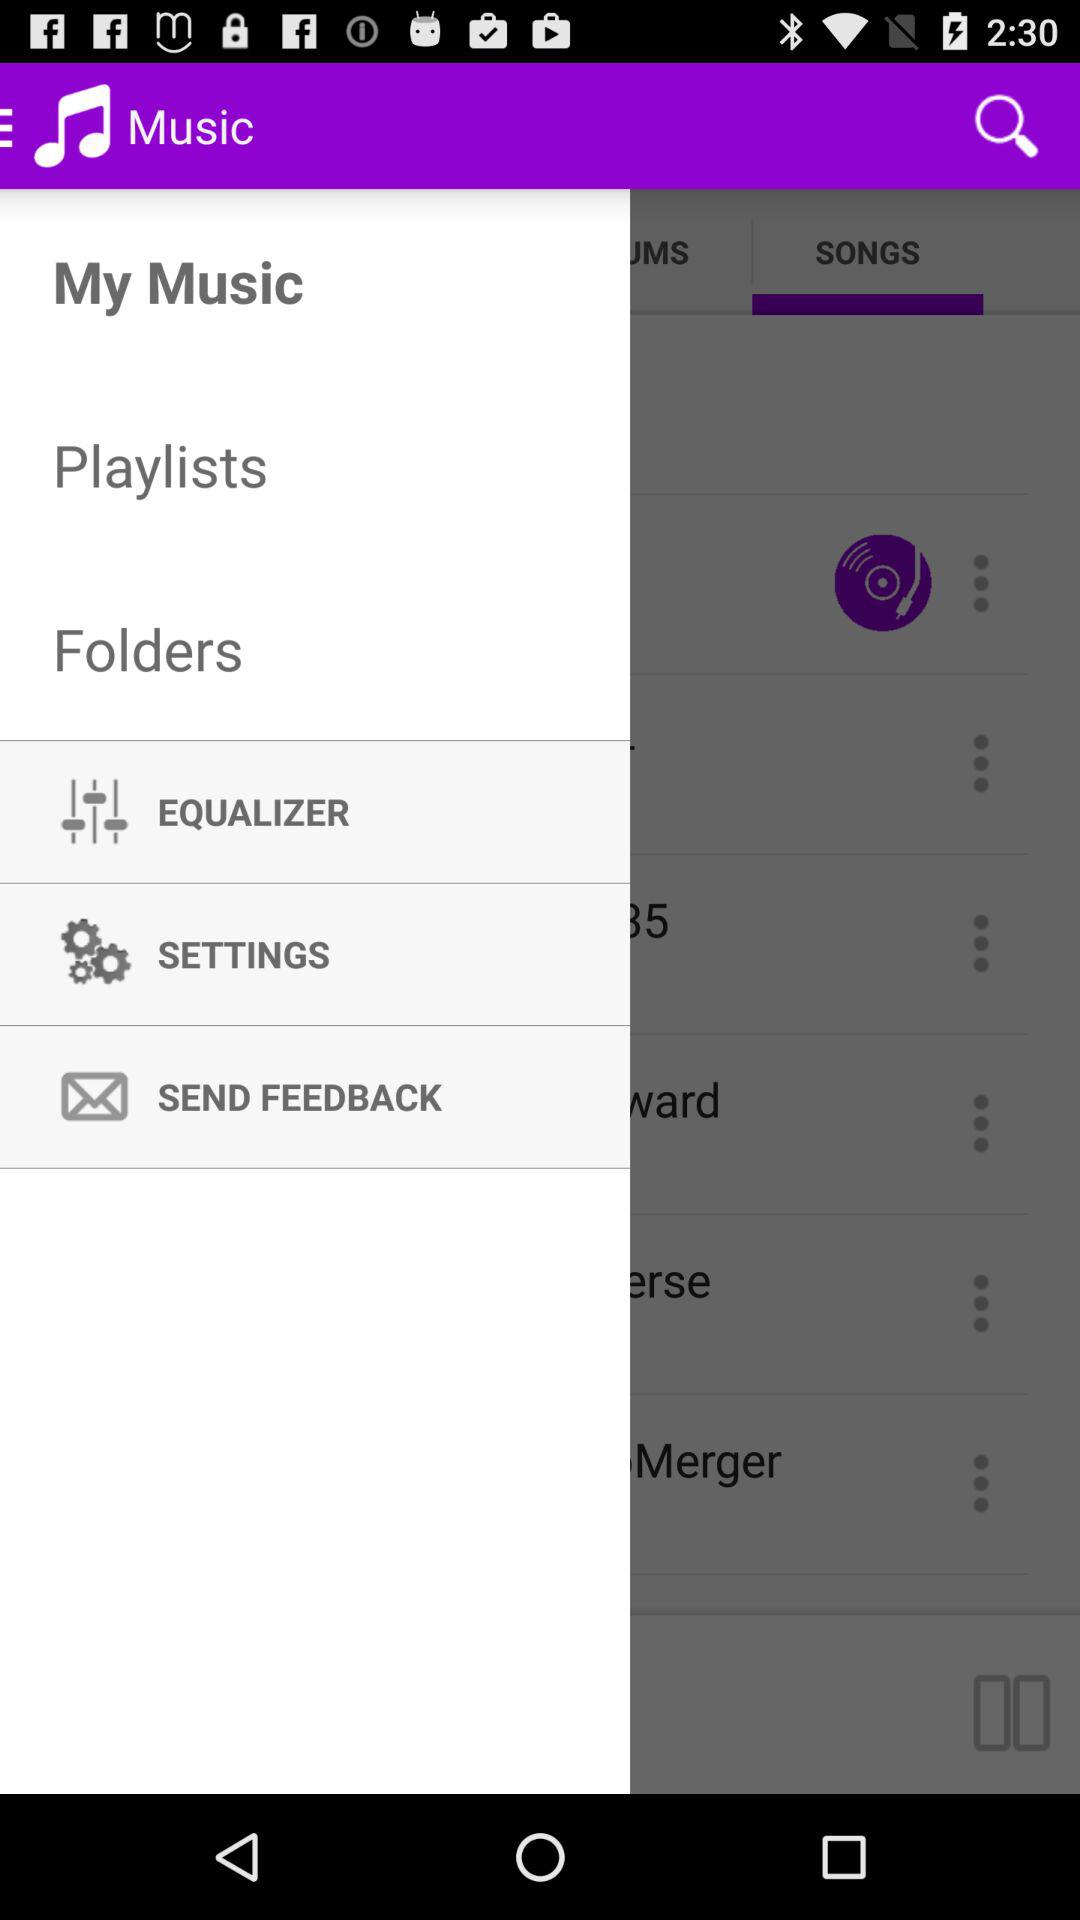Which item is selected in the menu? The selected item is "My Music". 